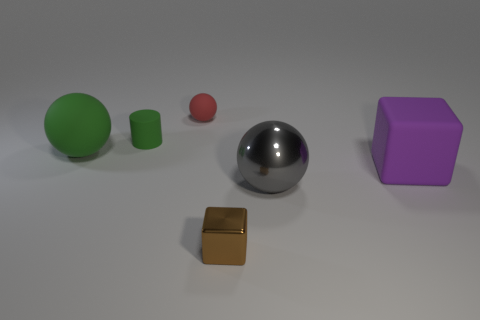Add 2 big green spheres. How many objects exist? 8 Subtract all large green matte balls. How many balls are left? 2 Subtract all blocks. How many objects are left? 4 Subtract all red cylinders. Subtract all purple blocks. How many cylinders are left? 1 Subtract all gray balls. How many green blocks are left? 0 Subtract all purple rubber things. Subtract all rubber cylinders. How many objects are left? 4 Add 4 small rubber cylinders. How many small rubber cylinders are left? 5 Add 5 blue rubber things. How many blue rubber things exist? 5 Subtract all green balls. How many balls are left? 2 Subtract 1 green cylinders. How many objects are left? 5 